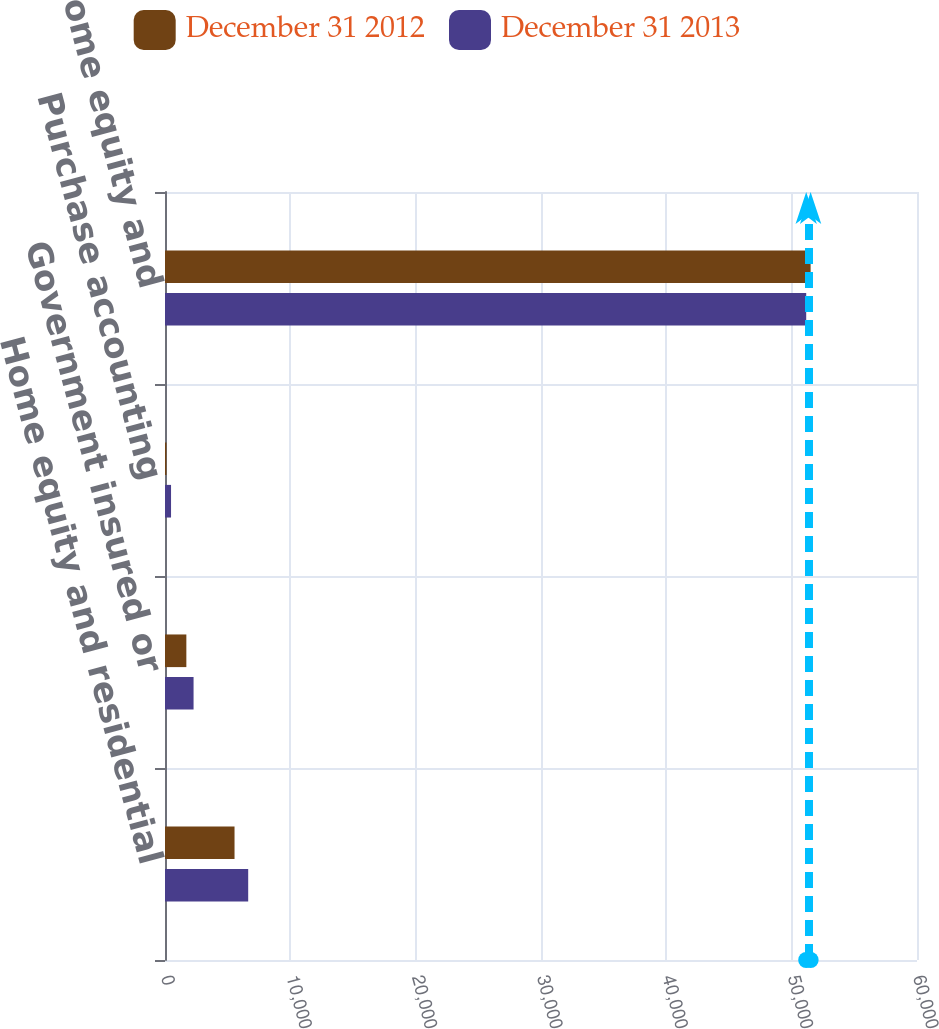<chart> <loc_0><loc_0><loc_500><loc_500><stacked_bar_chart><ecel><fcel>Home equity and residential<fcel>Government insured or<fcel>Purchase accounting<fcel>Total home equity and<nl><fcel>December 31 2012<fcel>5548<fcel>1704<fcel>116<fcel>51512<nl><fcel>December 31 2013<fcel>6638<fcel>2279<fcel>482<fcel>51160<nl></chart> 